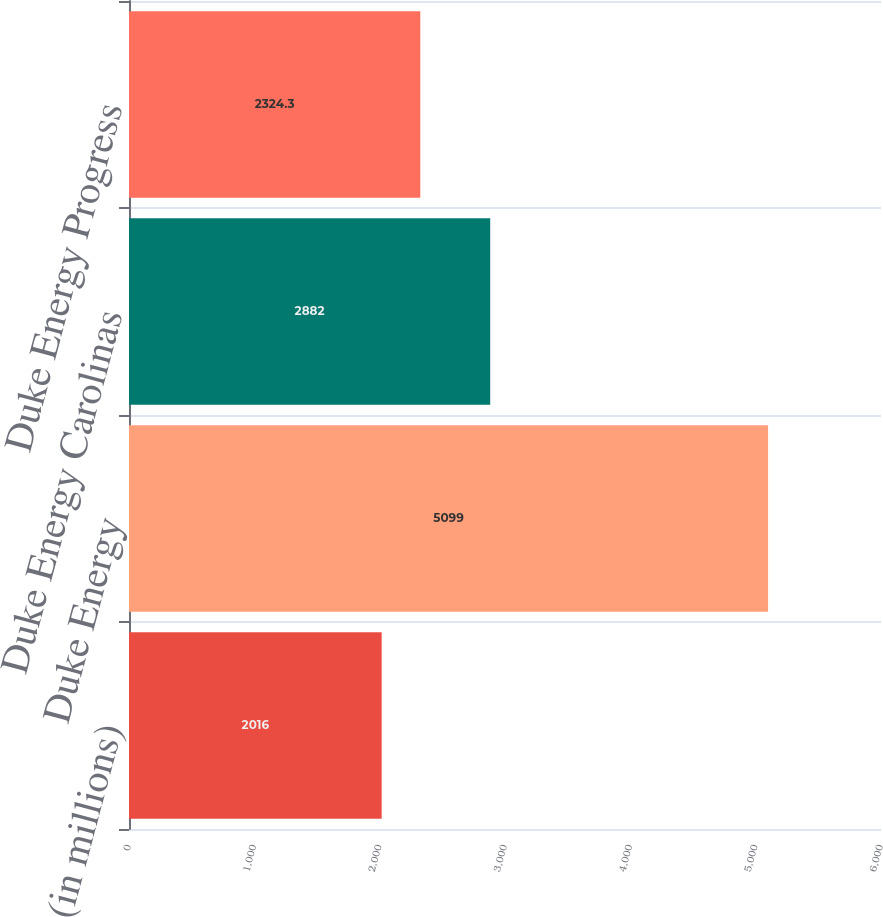Convert chart. <chart><loc_0><loc_0><loc_500><loc_500><bar_chart><fcel>(in millions)<fcel>Duke Energy<fcel>Duke Energy Carolinas<fcel>Duke Energy Progress<nl><fcel>2016<fcel>5099<fcel>2882<fcel>2324.3<nl></chart> 